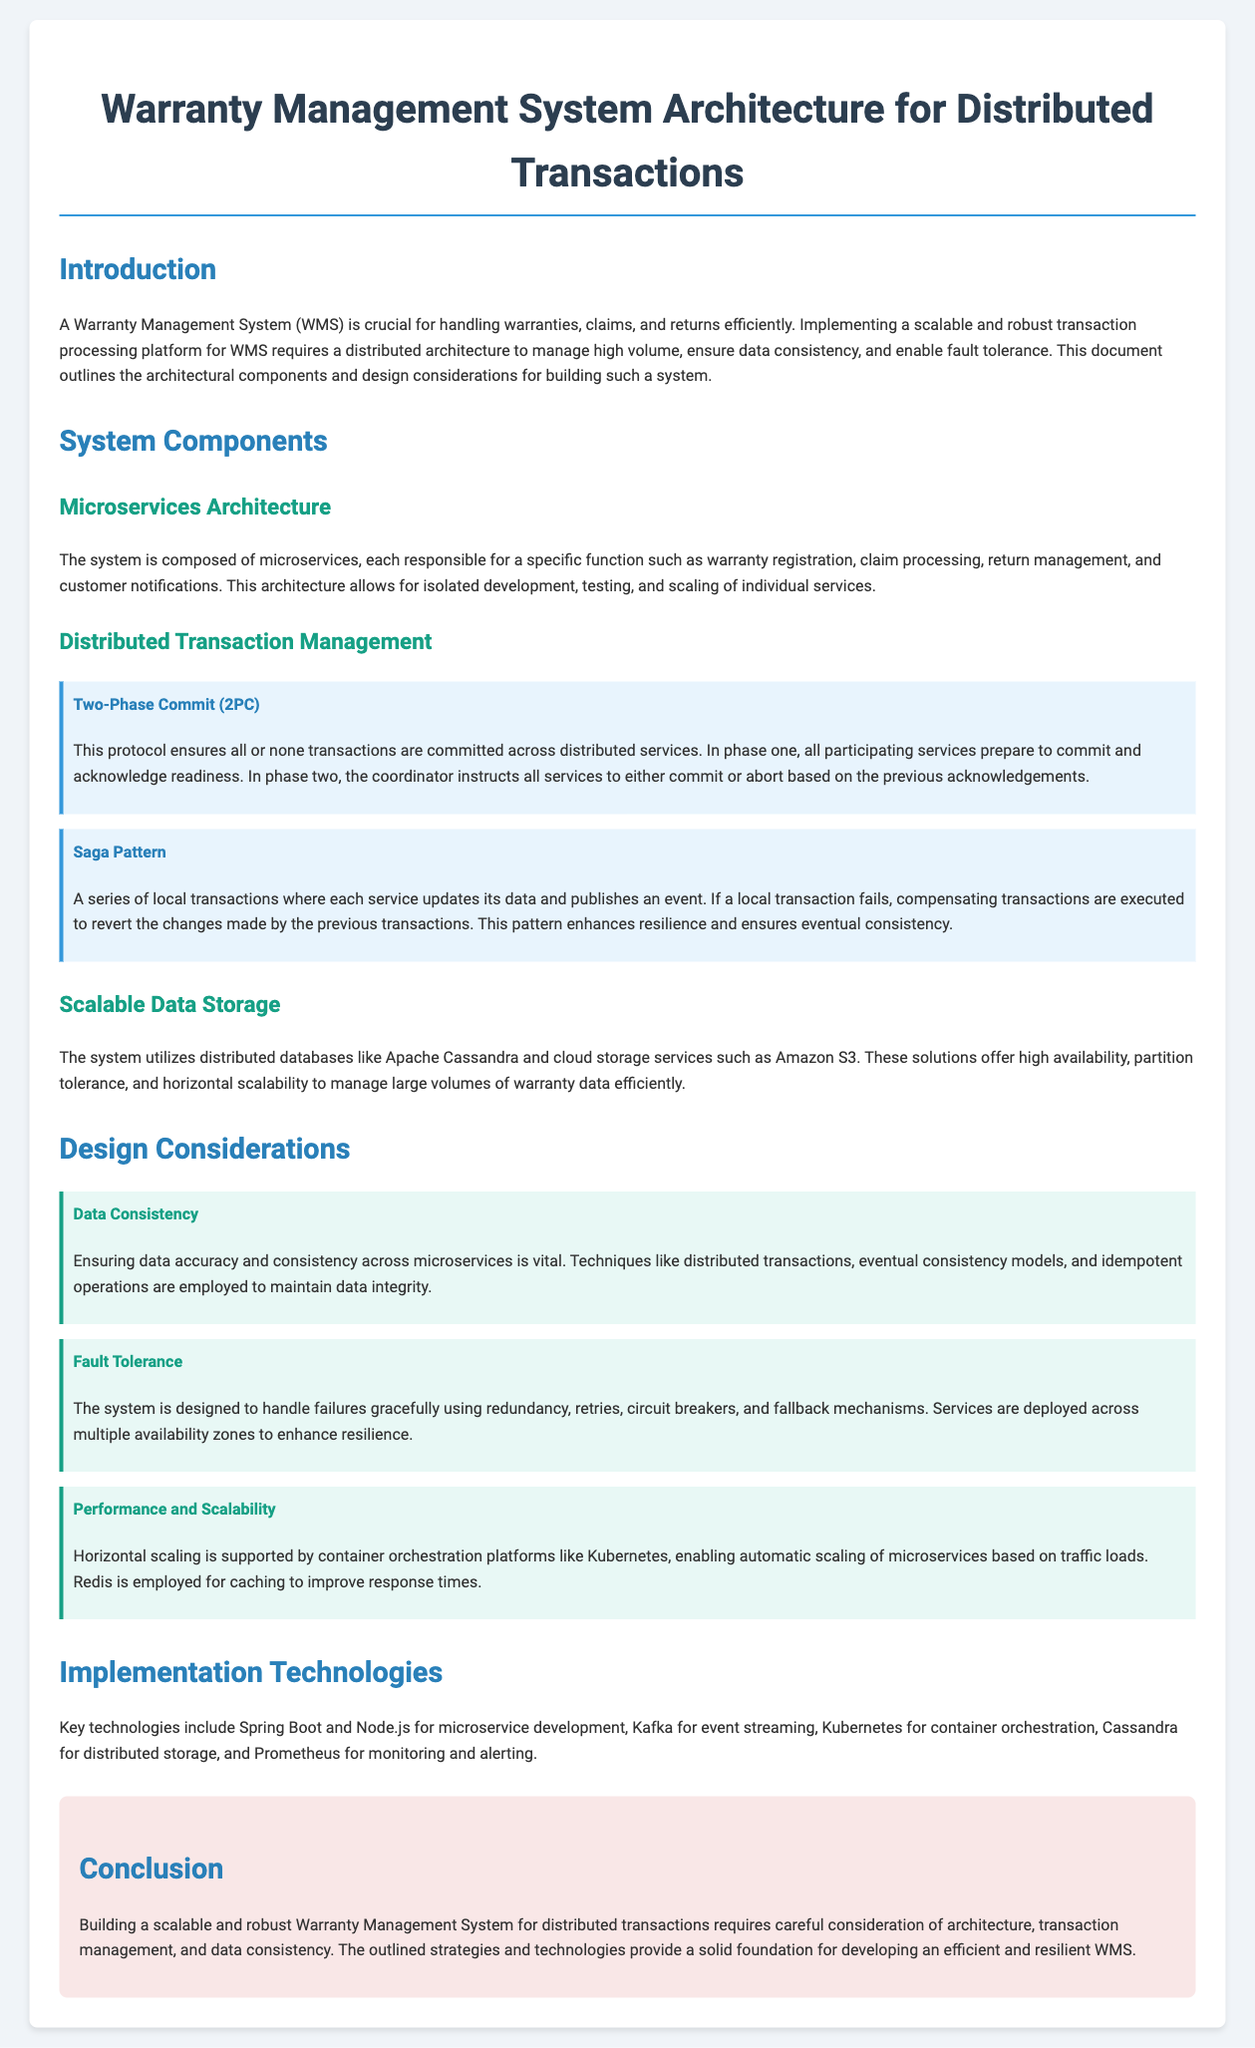What is the main purpose of a Warranty Management System? The Warranty Management System is crucial for handling warranties, claims, and returns efficiently.
Answer: handling warranties, claims, and returns What architectural style does the system utilize? The document mentions that the system is composed of microservices, allowing for isolated development and scaling.
Answer: Microservices Architecture What protocol is used for distributed transaction management in the document? The document describes the Two-Phase Commit protocol as a method for ensuring all or none transactions are committed.
Answer: Two-Phase Commit (2PC) What is one technology mentioned for microservice development? The document lists Spring Boot as a key technology used for developing microservices in the system.
Answer: Spring Boot How does the system ensure data consistency? The document explains that techniques like distributed transactions, eventual consistency models, and idempotent operations are used to maintain data integrity.
Answer: Distributed transactions, eventual consistency models, idempotent operations What is a key consideration for handling system failures? The document states that using redundancy, retries, circuit breakers, and fallback mechanisms are important for fault tolerance.
Answer: Redundancy, retries, circuit breakers, fallback mechanisms Which database technology is mentioned for scalable data storage? Apache Cassandra is stated as a distributed database solution utilized by the system for managing large volumes of warranty data.
Answer: Apache Cassandra What is utilized for event streaming in the architecture? The document specifies Kafka as the technology used for event streaming in the Warranty Management System.
Answer: Kafka What is stated as a benefit of using container orchestration platforms like Kubernetes? The document mentions that Kubernetes supports horizontal scaling and enables automatic scaling based on traffic loads.
Answer: Horizontal scaling and automatic scaling 